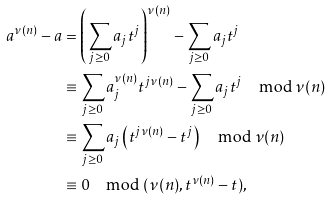<formula> <loc_0><loc_0><loc_500><loc_500>a ^ { \nu ( n ) } - a & = \left ( \sum _ { j \geq 0 } a _ { j } t ^ { j } \right ) ^ { \nu ( n ) } - \sum _ { j \geq 0 } a _ { j } t ^ { j } \\ & \equiv \sum _ { j \geq 0 } a _ { j } ^ { \nu ( n ) } t ^ { j \nu ( n ) } - \sum _ { j \geq 0 } a _ { j } t ^ { j } \mod \nu ( n ) \\ & \equiv \sum _ { j \geq 0 } a _ { j } \left ( t ^ { j \nu ( n ) } - t ^ { j } \right ) \mod \nu ( n ) \\ & \equiv 0 \mod ( \nu ( n ) , t ^ { \nu ( n ) } - t ) ,</formula> 